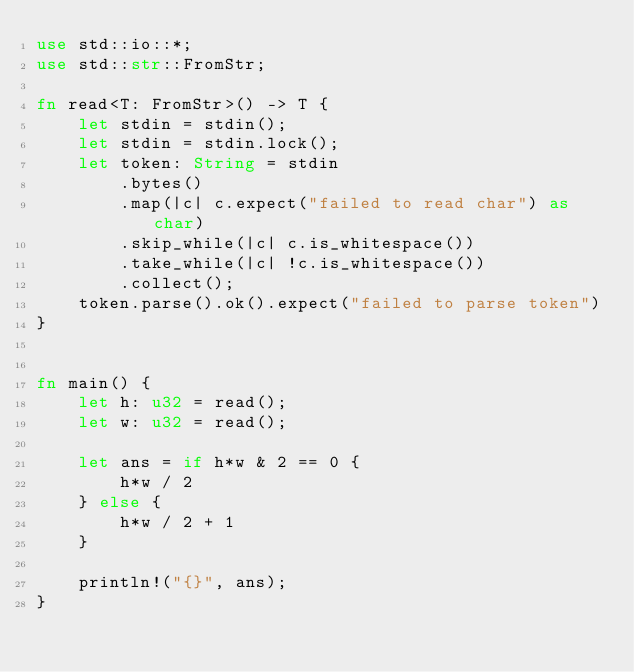<code> <loc_0><loc_0><loc_500><loc_500><_Rust_>use std::io::*;
use std::str::FromStr;

fn read<T: FromStr>() -> T {
    let stdin = stdin();
    let stdin = stdin.lock();
    let token: String = stdin
        .bytes()
        .map(|c| c.expect("failed to read char") as char) 
        .skip_while(|c| c.is_whitespace())
        .take_while(|c| !c.is_whitespace())
        .collect();
    token.parse().ok().expect("failed to parse token")
}


fn main() {
    let h: u32 = read();
    let w: u32 = read();
    
    let ans = if h*w & 2 == 0 {
        h*w / 2
    } else {
        h*w / 2 + 1
    }
    
    println!("{}", ans);
}
</code> 